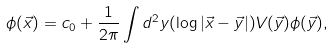Convert formula to latex. <formula><loc_0><loc_0><loc_500><loc_500>\phi ( \vec { x } ) = c _ { 0 } + \frac { 1 } { 2 \pi } \int d ^ { 2 } y ( \log | \vec { x } - \vec { y } | ) V ( \vec { y } ) \phi ( \vec { y } ) ,</formula> 